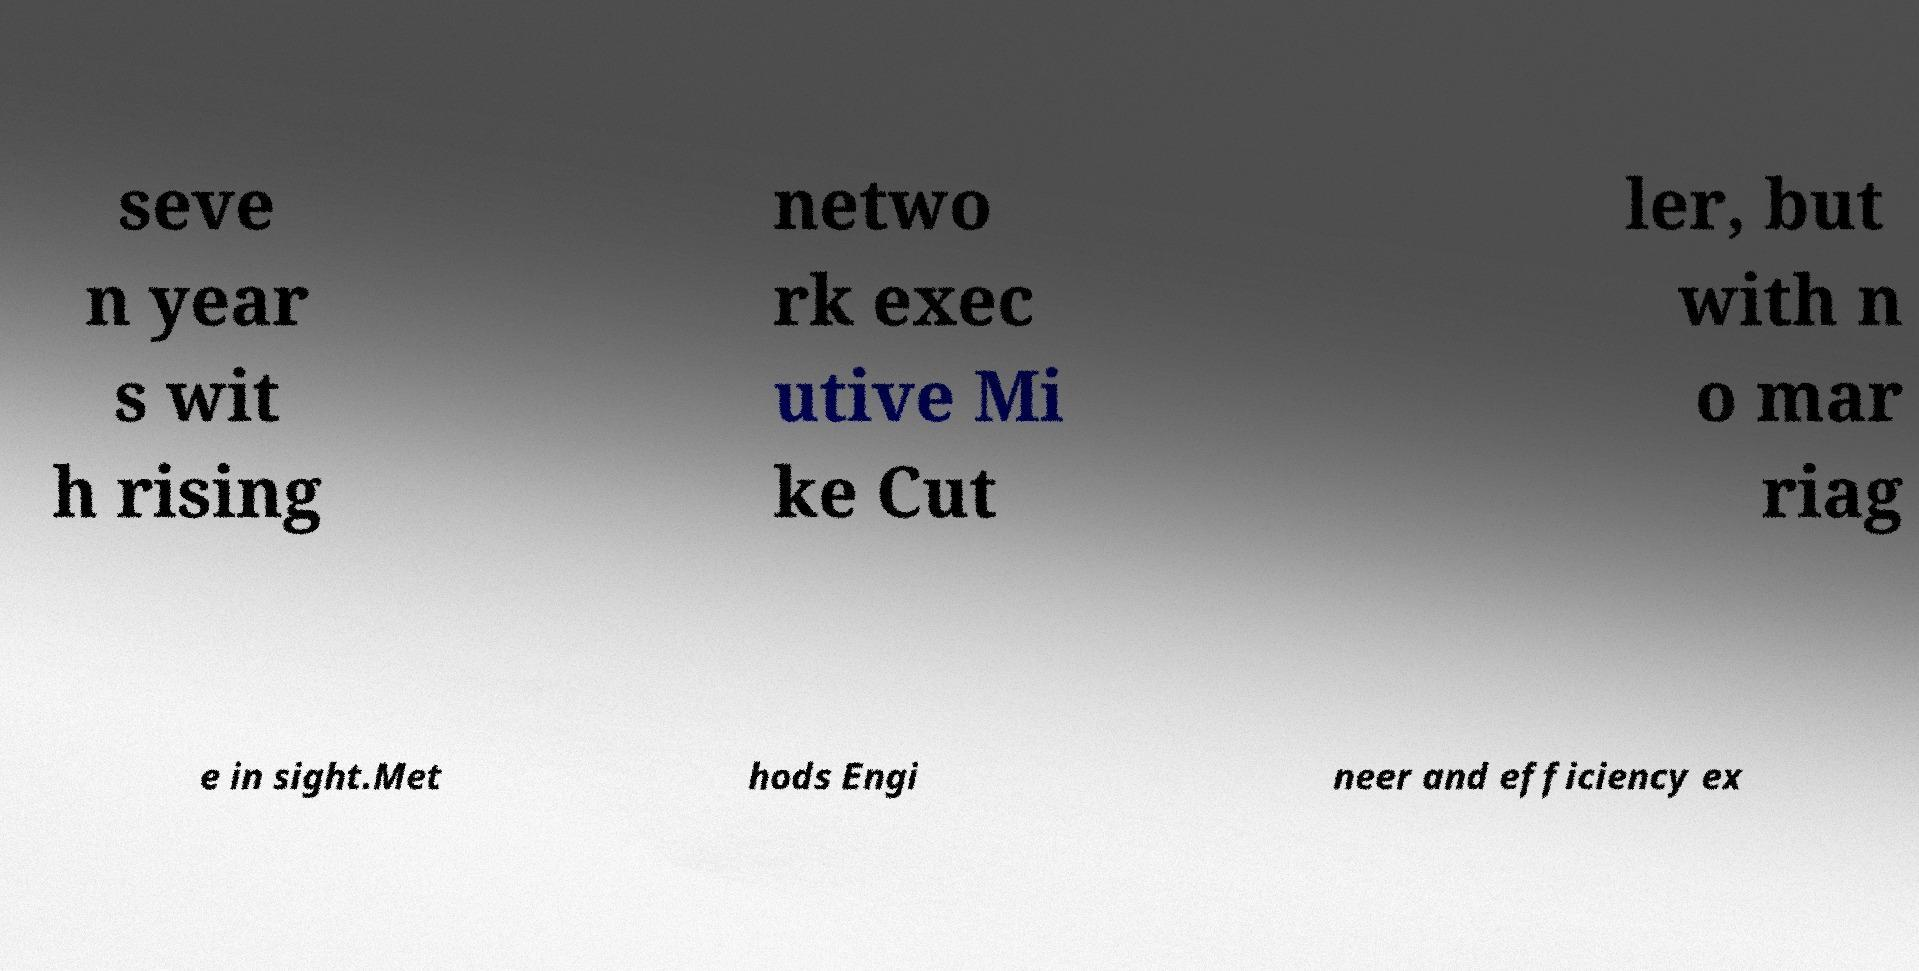What messages or text are displayed in this image? I need them in a readable, typed format. seve n year s wit h rising netwo rk exec utive Mi ke Cut ler, but with n o mar riag e in sight.Met hods Engi neer and efficiency ex 